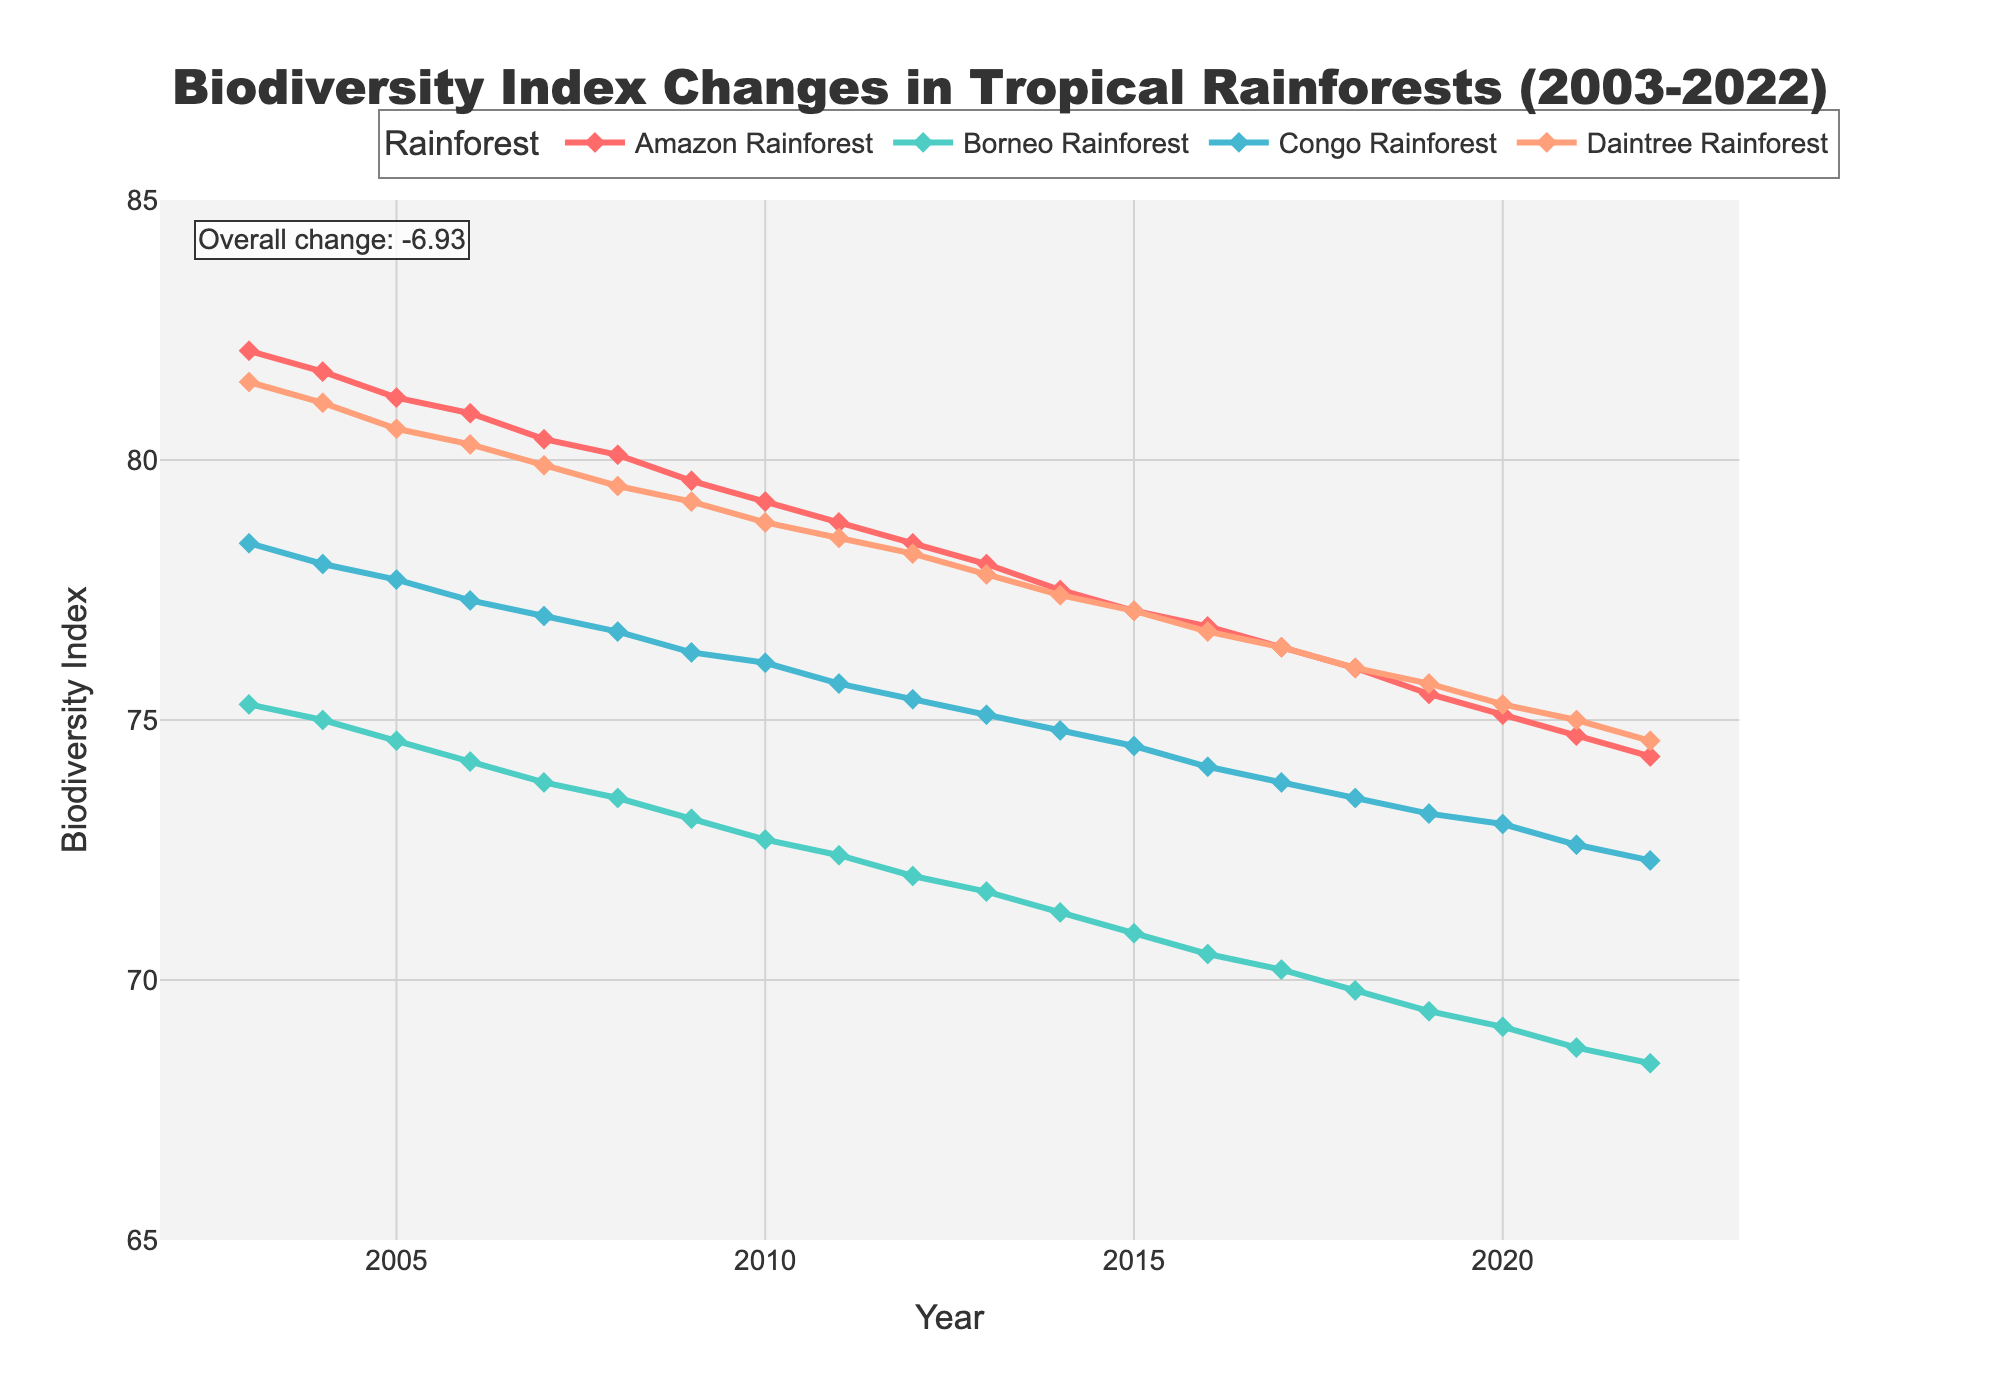What is the title of the figure? The title of the figure is located at the top and indicates the subject of the visualized data.
Answer: "Biodiversity Index Changes in Tropical Rainforests (2003-2022)" What does the y-axis represent? The y-axis represents the Biodiversity Index, which is a numerical value indicating the biodiversity level.
Answer: Biodiversity Index How many rainforest areas are shown in the plot? By observing the legend, we can identify the number of unique colors and labels representing different rainforest areas.
Answer: 4 Which rainforest shows the highest biodiversity index in 2022? Looking at the endpoint of each line in 2022 on the x-axis and then checking the corresponding y-values, identify the highest point.
Answer: Amazon Rainforest What is the overall change in the biodiversity index from 2003 to 2022 for the Amazon Rainforest? Subtract the biodiversity index value in 2022 from the value in 2003 for the Amazon Rainforest.
Answer: 82.1 - 74.3 = 7.8 How does the trend of Borneo Rainforest's biodiversity index compare to that of Congo Rainforest? Observing both lines over the years, note if both trends are increasing, decreasing, or stable and detail their slopes/steepness to compare decreases.
Answer: Both trends are decreasing, Borneo faster than Congo What was the biodiversity index of Daintree Rainforest in 2010? Find the value for the Daintree Rainforest at the year 2010 by checking the position on the y-axis.
Answer: 78.8 Between which consecutive years did the Amazon Rainforest experience the largest drop in biodiversity index? Calculate the year-to-year differences in biodiversity index for the Amazon Rainforest, then identify the largest decrement.
Answer: Between 2003 and 2004 What is the average Biodiversity Index for all four rainforests in 2021? Sum up the biodiversity indexes of all four rainforests in 2021 and divide by the number of rainforests.
Answer: (74.7 + 68.7+ 72.6 + 75.0) / 4 = 72.75 